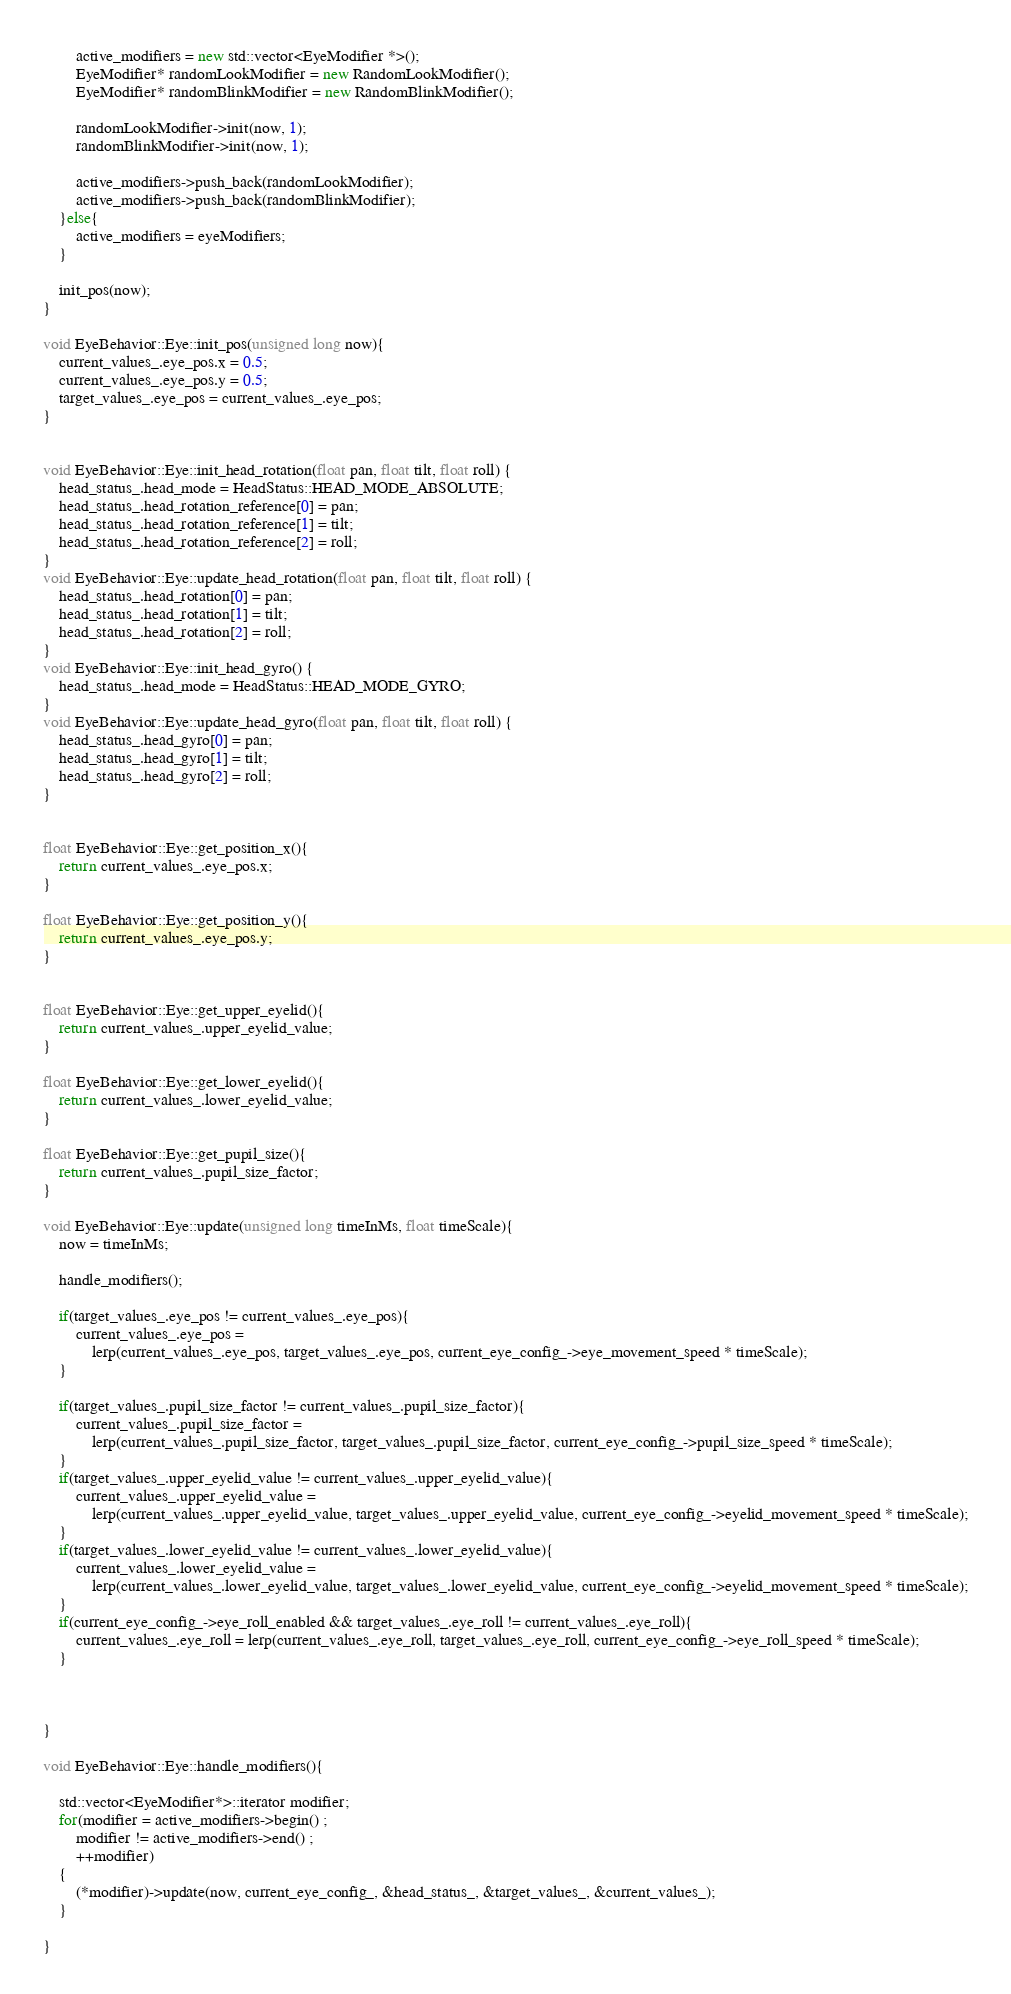<code> <loc_0><loc_0><loc_500><loc_500><_C++_>        active_modifiers = new std::vector<EyeModifier *>();
        EyeModifier* randomLookModifier = new RandomLookModifier();
        EyeModifier* randomBlinkModifier = new RandomBlinkModifier();

        randomLookModifier->init(now, 1);
        randomBlinkModifier->init(now, 1);

        active_modifiers->push_back(randomLookModifier);
        active_modifiers->push_back(randomBlinkModifier);
    }else{
        active_modifiers = eyeModifiers;
    }

    init_pos(now);
}

void EyeBehavior::Eye::init_pos(unsigned long now){
    current_values_.eye_pos.x = 0.5;
    current_values_.eye_pos.y = 0.5;
    target_values_.eye_pos = current_values_.eye_pos;
}


void EyeBehavior::Eye::init_head_rotation(float pan, float tilt, float roll) {
    head_status_.head_mode = HeadStatus::HEAD_MODE_ABSOLUTE;
    head_status_.head_rotation_reference[0] = pan;
    head_status_.head_rotation_reference[1] = tilt;
    head_status_.head_rotation_reference[2] = roll;
}
void EyeBehavior::Eye::update_head_rotation(float pan, float tilt, float roll) {
    head_status_.head_rotation[0] = pan;
    head_status_.head_rotation[1] = tilt;
    head_status_.head_rotation[2] = roll;
}
void EyeBehavior::Eye::init_head_gyro() {
    head_status_.head_mode = HeadStatus::HEAD_MODE_GYRO;
}
void EyeBehavior::Eye::update_head_gyro(float pan, float tilt, float roll) {
    head_status_.head_gyro[0] = pan;
    head_status_.head_gyro[1] = tilt;
    head_status_.head_gyro[2] = roll;
}


float EyeBehavior::Eye::get_position_x(){
    return current_values_.eye_pos.x;
}

float EyeBehavior::Eye::get_position_y(){
    return current_values_.eye_pos.y;
}


float EyeBehavior::Eye::get_upper_eyelid(){
    return current_values_.upper_eyelid_value;
}

float EyeBehavior::Eye::get_lower_eyelid(){
    return current_values_.lower_eyelid_value;
}

float EyeBehavior::Eye::get_pupil_size(){
    return current_values_.pupil_size_factor;
}

void EyeBehavior::Eye::update(unsigned long timeInMs, float timeScale){
    now = timeInMs;

    handle_modifiers();

    if(target_values_.eye_pos != current_values_.eye_pos){
        current_values_.eye_pos = 
            lerp(current_values_.eye_pos, target_values_.eye_pos, current_eye_config_->eye_movement_speed * timeScale);
    }
    
    if(target_values_.pupil_size_factor != current_values_.pupil_size_factor){
        current_values_.pupil_size_factor = 
            lerp(current_values_.pupil_size_factor, target_values_.pupil_size_factor, current_eye_config_->pupil_size_speed * timeScale);
    }
    if(target_values_.upper_eyelid_value != current_values_.upper_eyelid_value){
        current_values_.upper_eyelid_value = 
            lerp(current_values_.upper_eyelid_value, target_values_.upper_eyelid_value, current_eye_config_->eyelid_movement_speed * timeScale);
    } 
    if(target_values_.lower_eyelid_value != current_values_.lower_eyelid_value){
        current_values_.lower_eyelid_value = 
            lerp(current_values_.lower_eyelid_value, target_values_.lower_eyelid_value, current_eye_config_->eyelid_movement_speed * timeScale);
    }
    if(current_eye_config_->eye_roll_enabled && target_values_.eye_roll != current_values_.eye_roll){
        current_values_.eye_roll = lerp(current_values_.eye_roll, target_values_.eye_roll, current_eye_config_->eye_roll_speed * timeScale);
    }

    

}

void EyeBehavior::Eye::handle_modifiers(){

    std::vector<EyeModifier*>::iterator modifier;
    for(modifier = active_modifiers->begin() ;
        modifier != active_modifiers->end() ;
        ++modifier)
    {
        (*modifier)->update(now, current_eye_config_, &head_status_, &target_values_, &current_values_);
    }

}</code> 